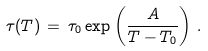Convert formula to latex. <formula><loc_0><loc_0><loc_500><loc_500>\tau ( T ) \, = \, \tau _ { 0 } \exp \left ( \frac { A } { T - T _ { 0 } } \right ) \, .</formula> 